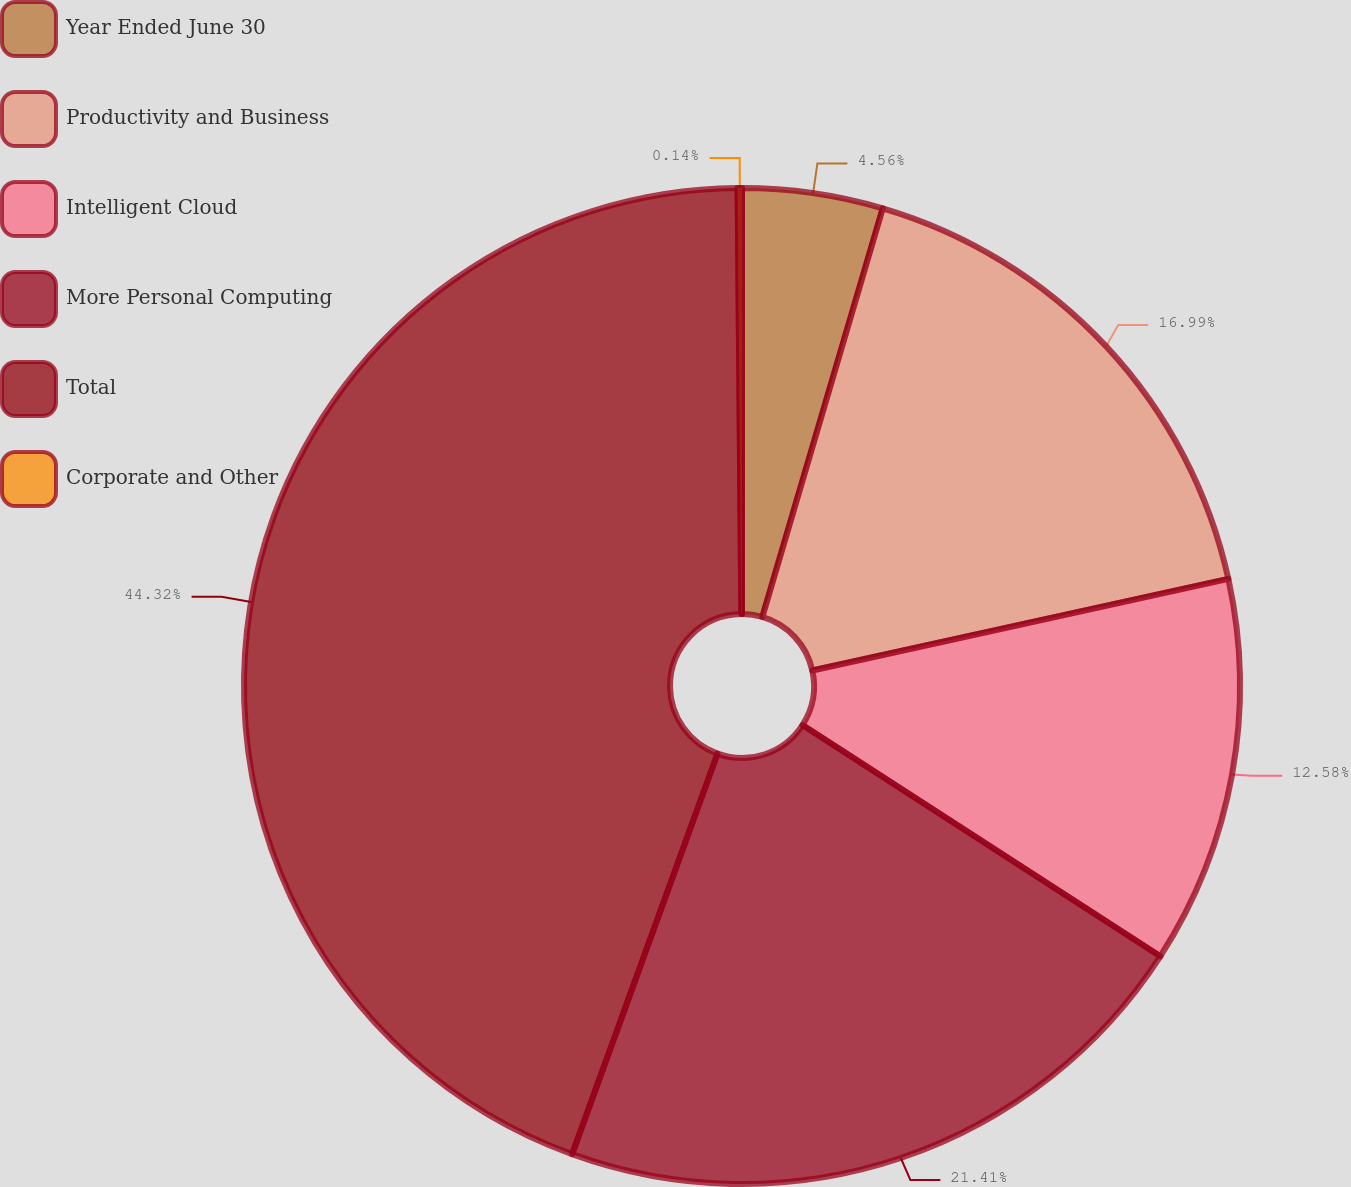<chart> <loc_0><loc_0><loc_500><loc_500><pie_chart><fcel>Year Ended June 30<fcel>Productivity and Business<fcel>Intelligent Cloud<fcel>More Personal Computing<fcel>Total<fcel>Corporate and Other<nl><fcel>4.56%<fcel>16.99%<fcel>12.58%<fcel>21.41%<fcel>44.32%<fcel>0.14%<nl></chart> 